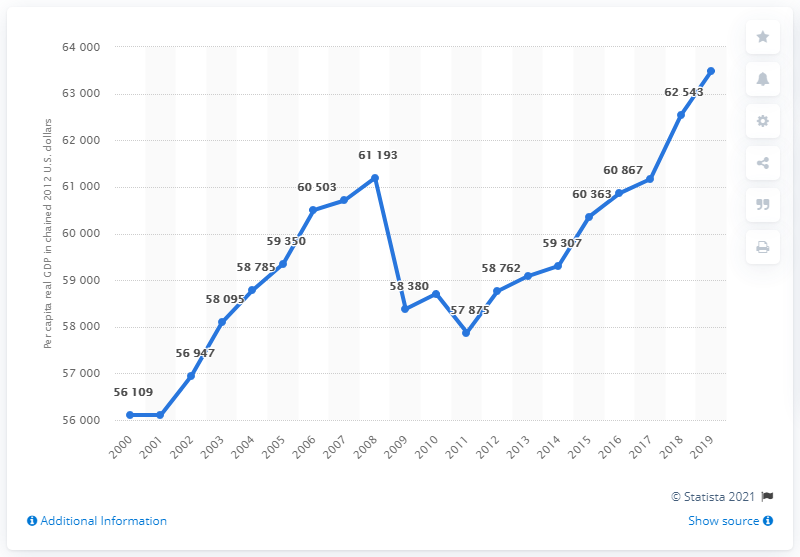Mention a couple of crucial points in this snapshot. In 2012, the per capita real GDP of New Jersey was 63,492, adjusted for inflation using a chain-weighted price index. 